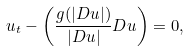<formula> <loc_0><loc_0><loc_500><loc_500>u _ { t } - \left ( \frac { g ( | D u | ) } { | D u | } D u \right ) = 0 ,</formula> 